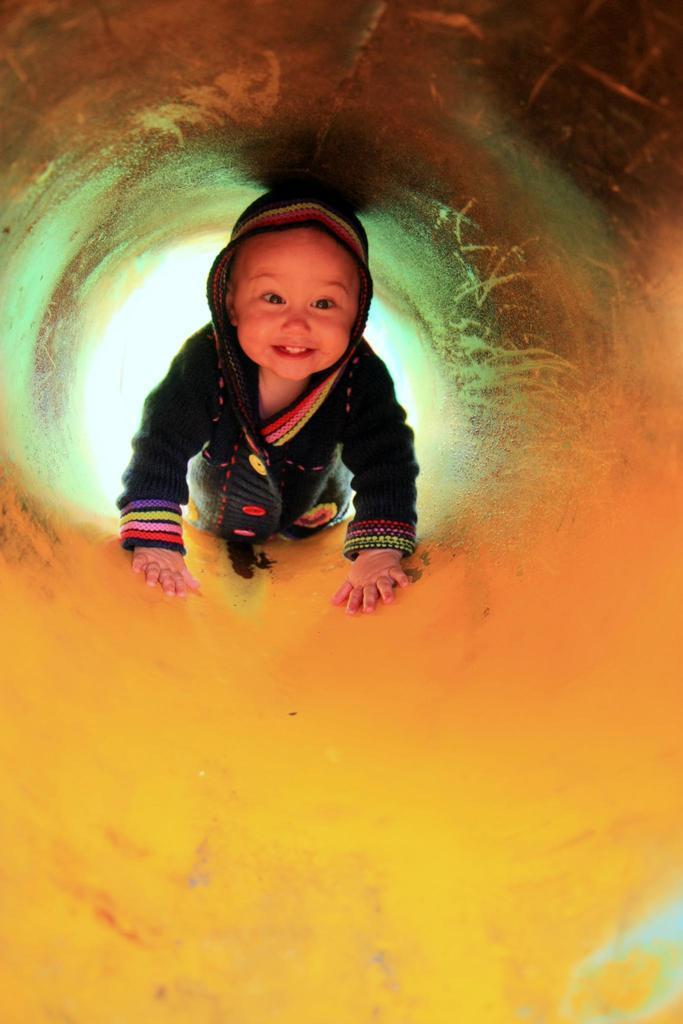Please provide a concise description of this image. In this picture we can see a child on a yellow surface. 